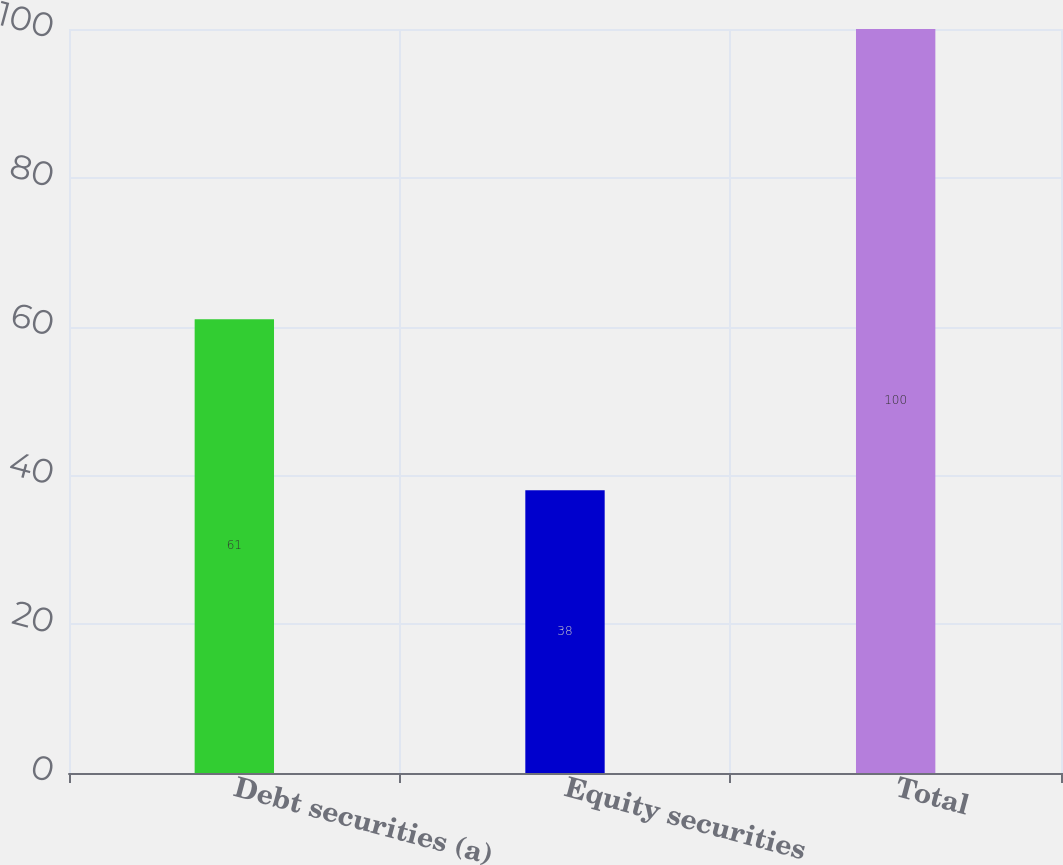Convert chart. <chart><loc_0><loc_0><loc_500><loc_500><bar_chart><fcel>Debt securities (a)<fcel>Equity securities<fcel>Total<nl><fcel>61<fcel>38<fcel>100<nl></chart> 